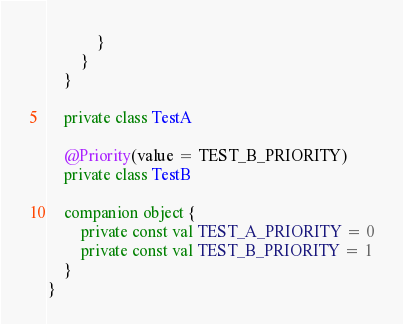Convert code to text. <code><loc_0><loc_0><loc_500><loc_500><_Kotlin_>			}
		}
	}

	private class TestA

	@Priority(value = TEST_B_PRIORITY)
	private class TestB

	companion object {
		private const val TEST_A_PRIORITY = 0
		private const val TEST_B_PRIORITY = 1
	}
}
</code> 